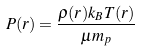<formula> <loc_0><loc_0><loc_500><loc_500>P ( r ) = \frac { \rho ( r ) k _ { B } T ( r ) } { \mu m _ { p } }</formula> 